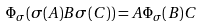Convert formula to latex. <formula><loc_0><loc_0><loc_500><loc_500>\Phi _ { \sigma } ( \sigma ( A ) B \sigma ( C ) ) = A \Phi _ { \sigma } ( B ) C</formula> 